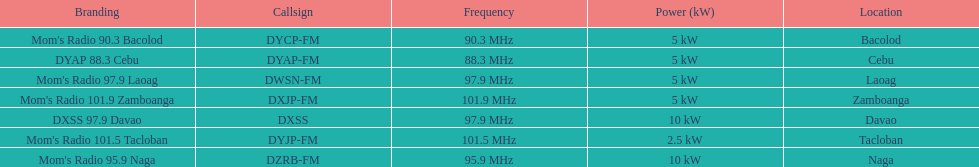What are the total number of radio stations on this list? 7. 